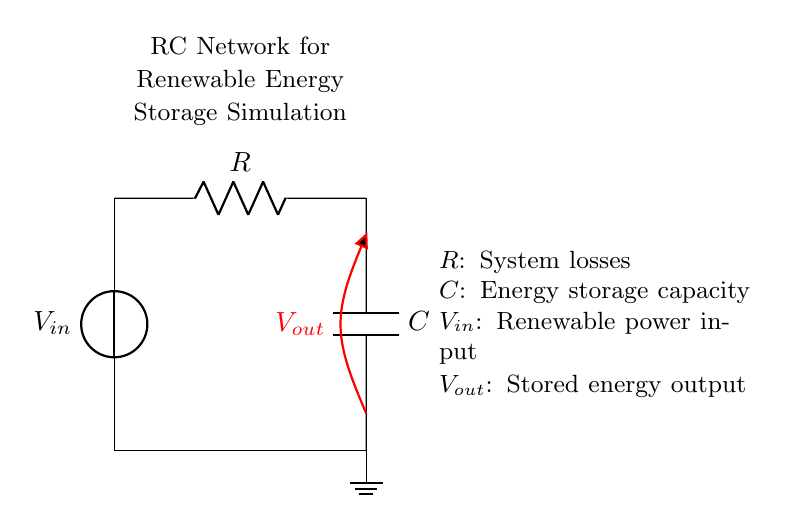What is the input voltage source labeled as? The circuit shows an input voltage source, which is labeled as V-in. It represents the renewable power input in the circuit.
Answer: V-in What does the resistor represent in the circuit? The resistor, labeled as R, represents system losses or energy dissipation in the renewable energy storage simulation.
Answer: System losses What is the role of the capacitor in this circuit? The capacitor, labeled as C, represents energy storage capacity in the renewable energy system. It stores the energy that is generated and can be released as needed.
Answer: Energy storage capacity What is the output voltage labeled as in the circuit? The output voltage is labeled as V-out. It represents the voltage across the capacitor and indicates the stored energy output from the system.
Answer: V-out How does the energy storage in this circuit occur? Energy storage occurs through the charging of the capacitor by the current flowing from the input voltage source, while the resistor affects the charging rate and energy loss. This dynamic forms the basis for simulating energy storage.
Answer: Through the capacitor What is the relationship between the resistor and capacitor in this circuit? The resistor and capacitor form an RC time constant where the resistor controls the discharge rate of the capacitor, affecting how quickly it can store and release energy, which is critical in renewable power systems.
Answer: RC time constant 